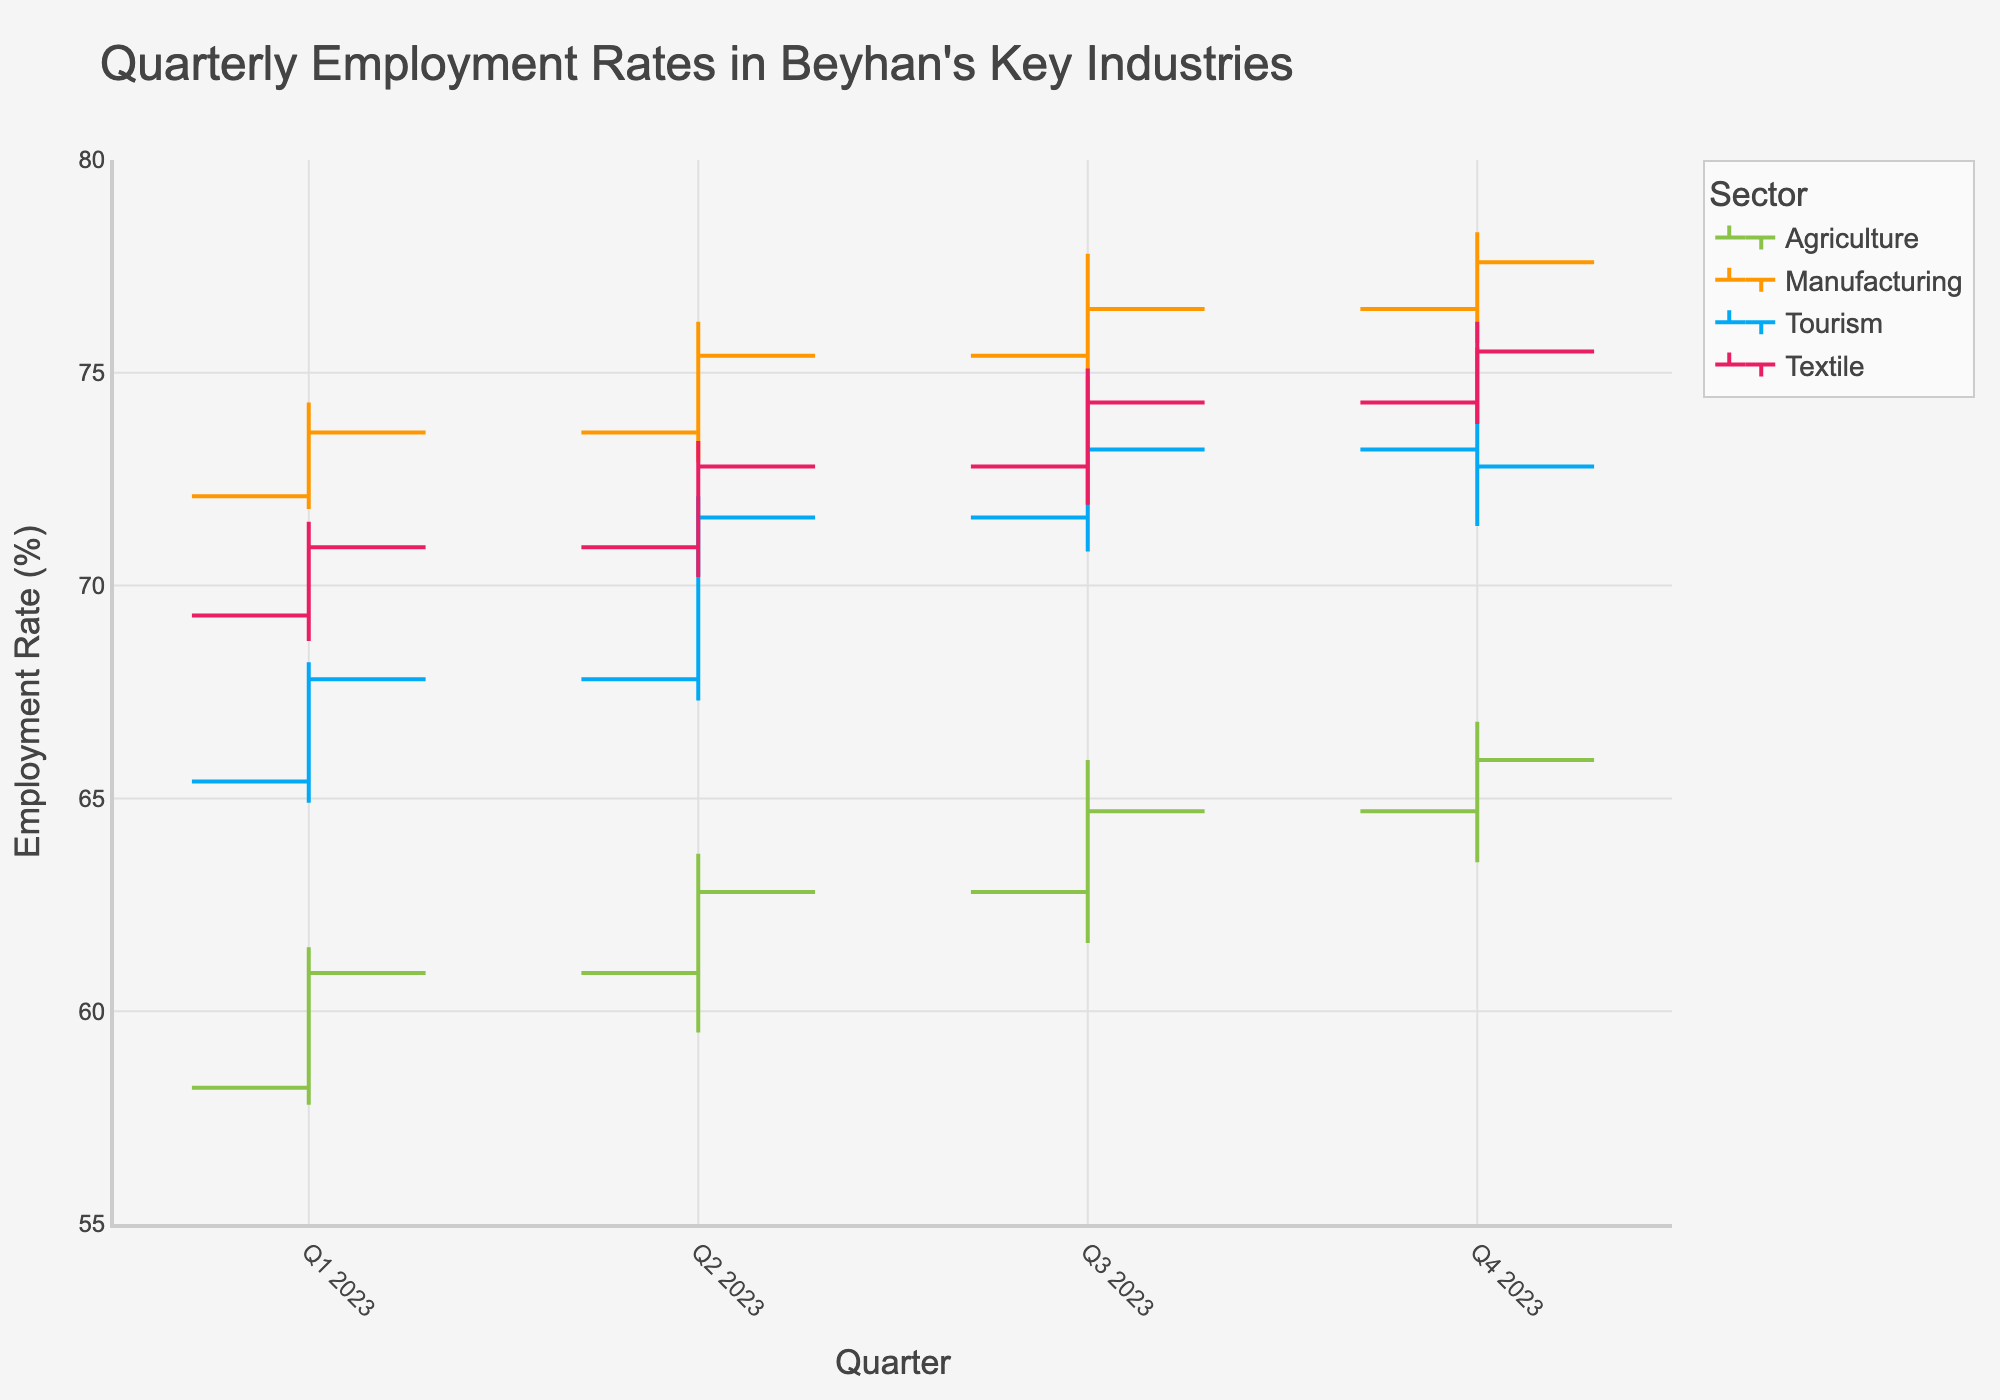What's the title of the figure? The title is displayed at the top of the figure. It reads 'Quarterly Employment Rates in Beyhan's Key Industries'.
Answer: Quarterly Employment Rates in Beyhan's Key Industries Which quarter had the highest employment rate in the agriculture sector? Look for the highest 'High' value in the Agriculture sector across all quarters. Q4 2023 had the highest value of 66.8%.
Answer: Q4 2023 What are the sectors represented in the figure? The legend on the figure lists the sectors: Agriculture, Manufacturing, Tourism, and Textile.
Answer: Agriculture, Manufacturing, Tourism, Textile Compare the opening employment rates of the Tourism sector between Q1 2023 and Q4 2023. What is the difference? The opening rate in Q1 2023 for Tourism is 65.4% and in Q4 2023 it is 73.2%. The difference is 73.2% - 65.4% = 7.8%.
Answer: 7.8% During which quarter did the Textile sector see the smallest range of employment rates (difference between high and low)? Calculate the range for Textile in each quarter:
- Q1 2023: 71.5 - 68.7 = 2.8
- Q2 2023: 73.4 - 70.2 = 3.2
- Q3 2023: 75.1 - 71.9 = 3.2
- Q4 2023: 76.2 - 73.8 = 2.4
Smallest range is in Q4 2023.
Answer: Q4 2023 What is the closing employment rate for Manufacturing in Q2 2023? The closing rate for Manufacturing in Q2 2023 is marked at 75.4%.
Answer: 75.4% Which sector showed an increasing trend in employment rates across all quarters? Review each sector's close value from Q1 to Q4:
- Agriculture: 60.9, 62.8, 64.7, 65.9 (increasing)
- Manufacturing: 73.6, 75.4, 76.5, 77.6 (increasing)
- Tourism: 67.8, 71.6, 73.2, 72.8 (not strictly increasing)
- Textile: 70.9, 72.8, 74.3, 75.5 (increasing)
Both Agriculture, Manufacturing, Textile show increasing trends.
Answer: Agriculture, Manufacturing, Textile Find the quarter with the highest closing rate in the Tourism sector and state the value. Look at the 'Close' values for Tourism by quarter:
- Q1 2023: 67.8
- Q2 2023: 71.6
- Q3 2023: 73.2
- Q4 2023: 72.8
Highest closing rate is in Q3 2023 with 73.2%.
Answer: Q3 2023, 73.2% What is the average opening employment rate for Manufacturing across all quarters? Add up the opening rates for each quarter and divide by the number of quarters (4):
(72.1 + 73.6 + 75.4 + 76.5) / 4 = 74.4%
Answer: 74.4% Which quarter had the lowest low employment rate in the Tourism sector and what was the value? The lowest 'Low' value for Tourism across all quarters:
- Q1 2023: 64.9
- Q2 2023: 67.3
- Q3 2023: 70.8
- Q4 2023: 71.4
Q1 2023 has the lowest value at 64.9%.
Answer: Q1 2023, 64.9% 